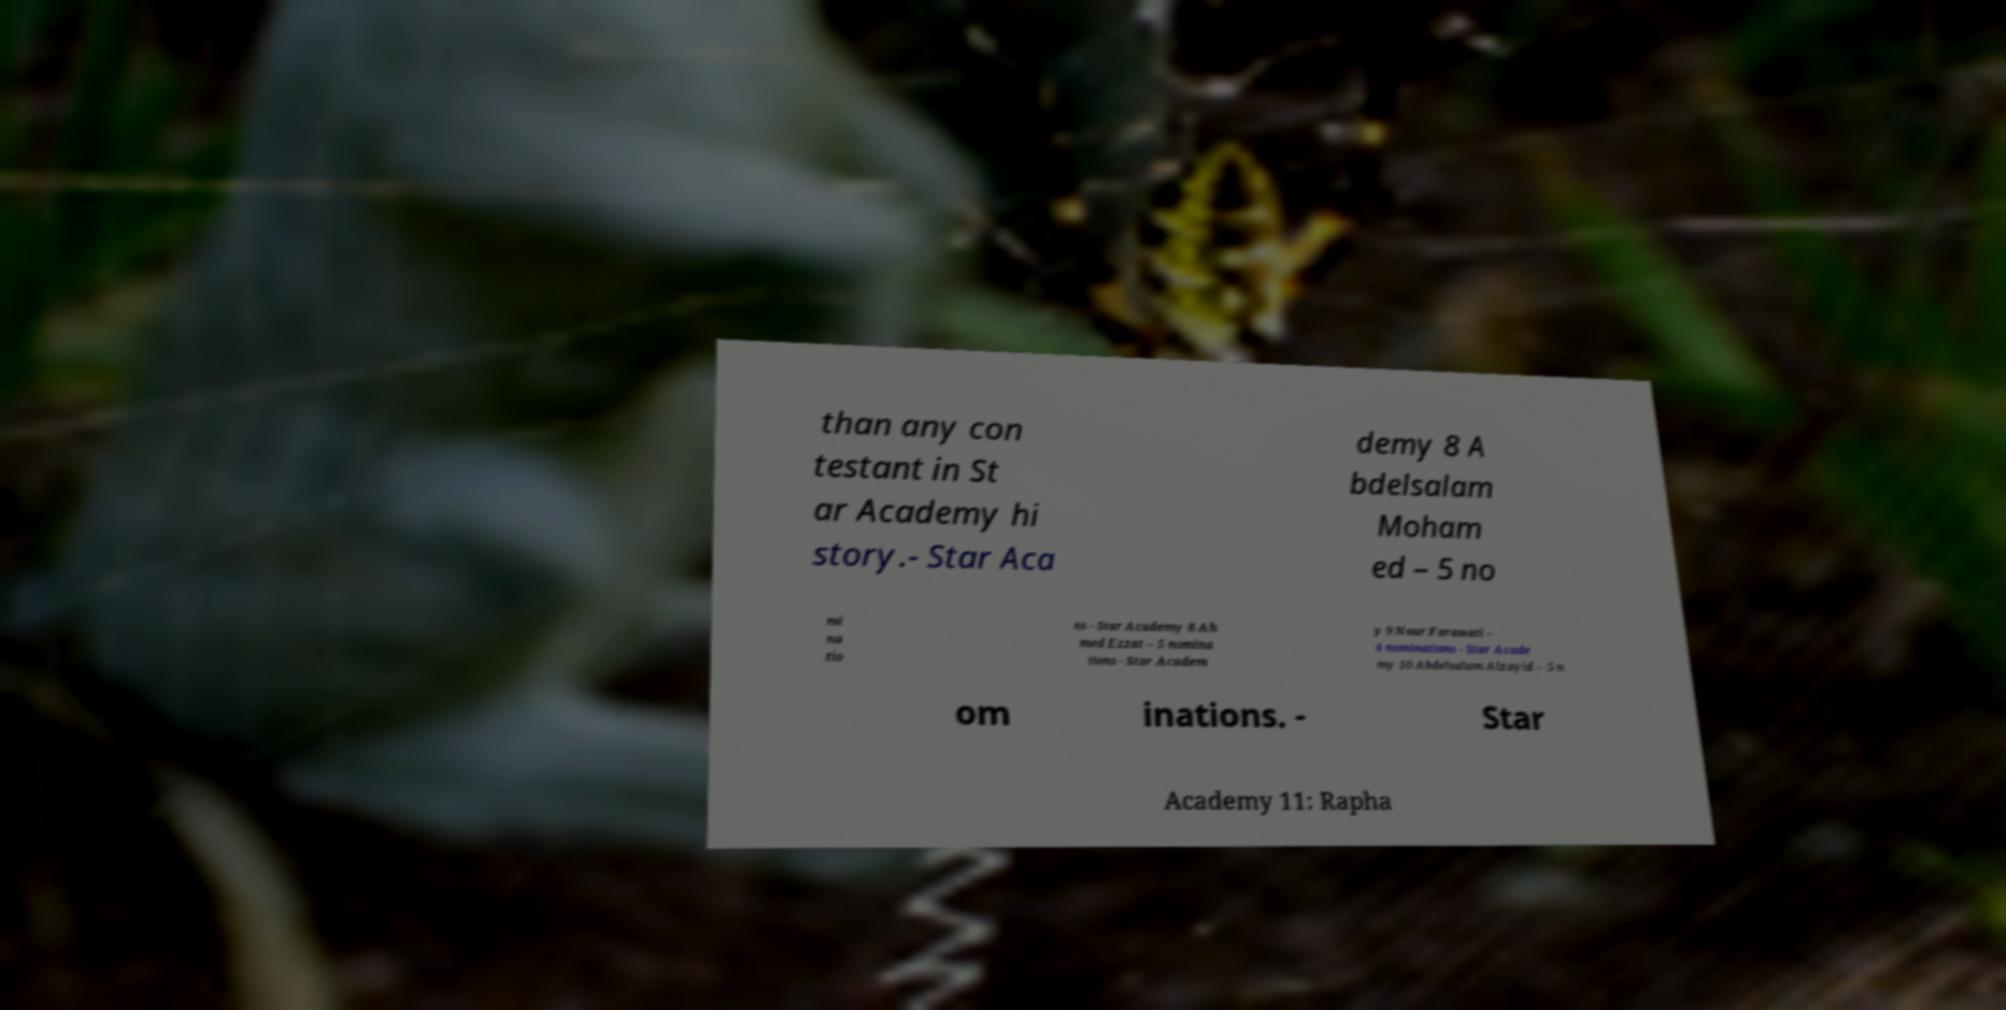Please identify and transcribe the text found in this image. than any con testant in St ar Academy hi story.- Star Aca demy 8 A bdelsalam Moham ed – 5 no mi na tio ns - Star Academy 8 Ah med Ezzat – 5 nomina tions - Star Academ y 9 Nour Farawati – 4 nominations - Star Acade my 10 Abdelsalam Alzayid – 5 n om inations. - Star Academy 11: Rapha 